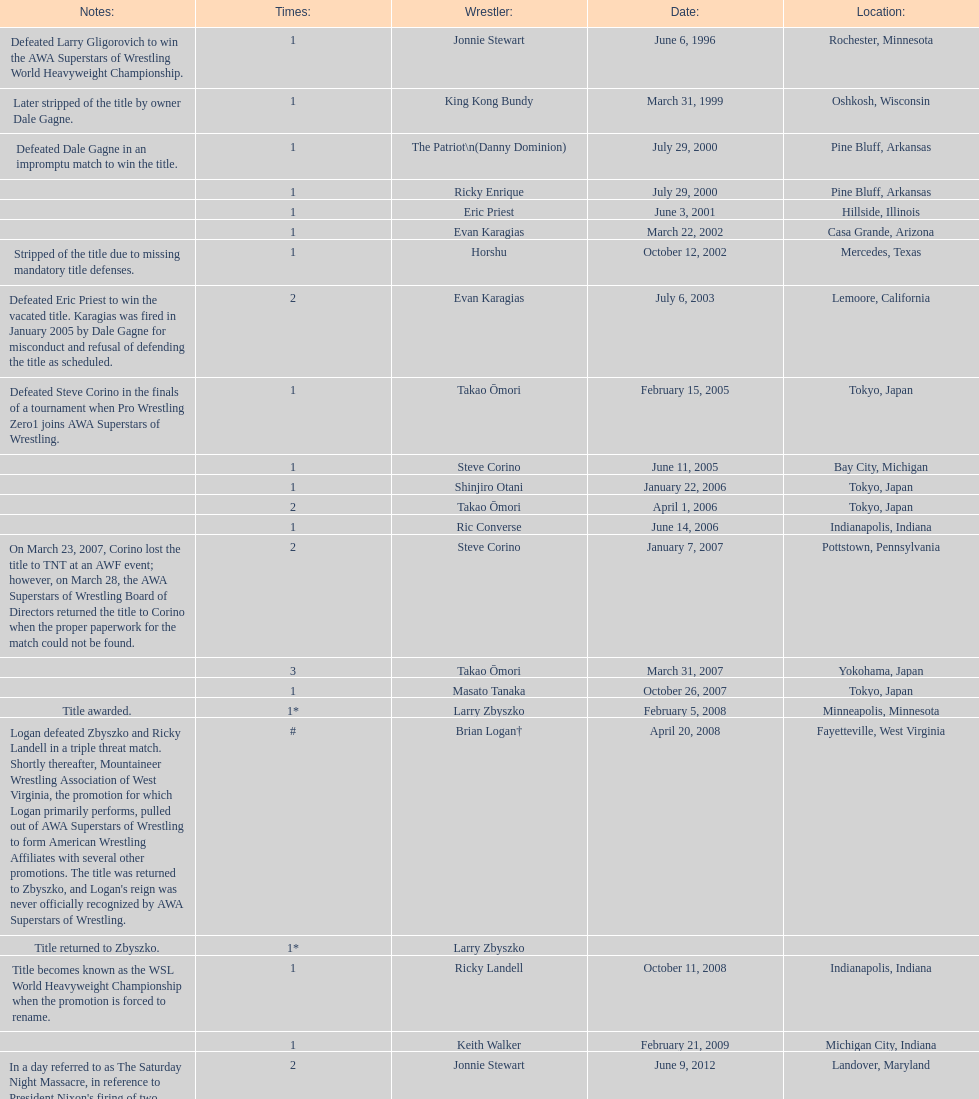Who is the only wsl title holder from texas? Horshu. 